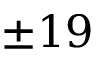<formula> <loc_0><loc_0><loc_500><loc_500>\pm 1 9</formula> 